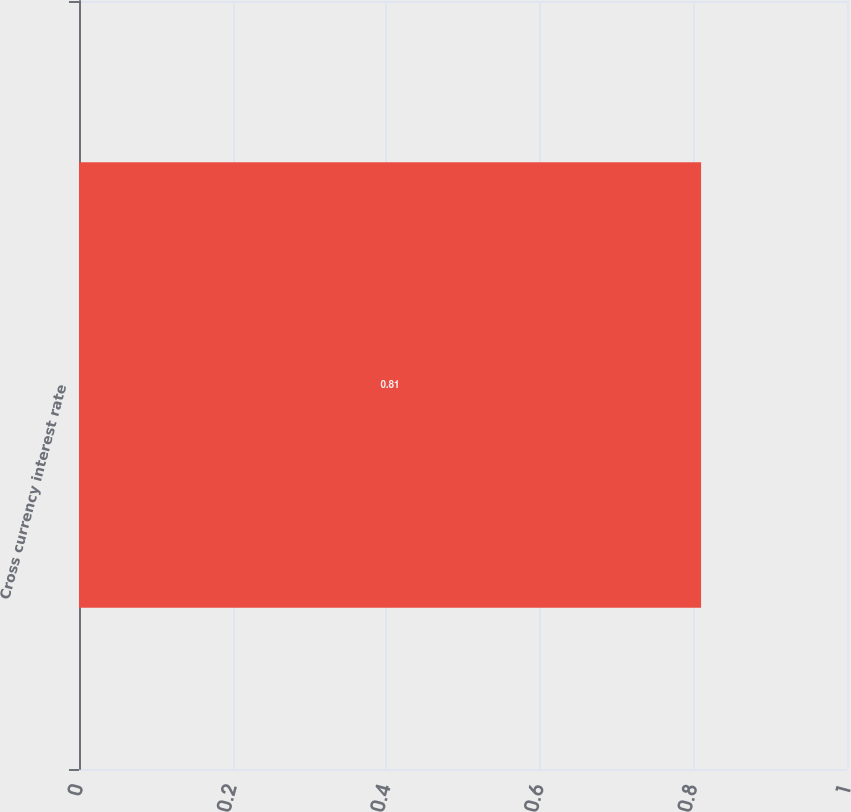Convert chart. <chart><loc_0><loc_0><loc_500><loc_500><bar_chart><fcel>Cross currency interest rate<nl><fcel>0.81<nl></chart> 